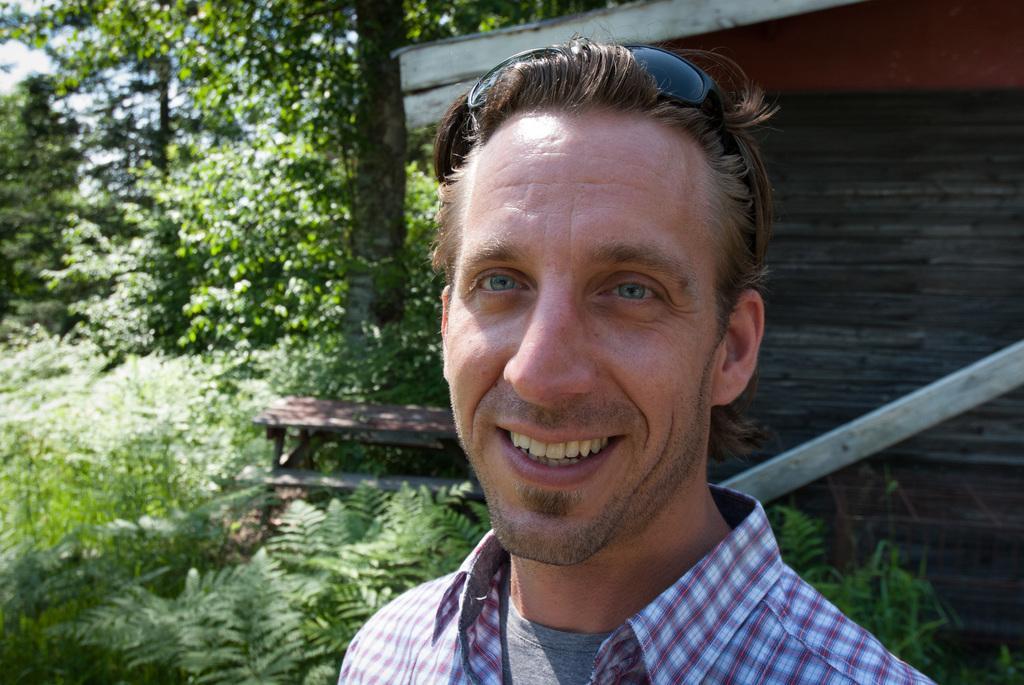How would you summarize this image in a sentence or two? There is a person. On the background we can see trees,wall,bench,sky. 